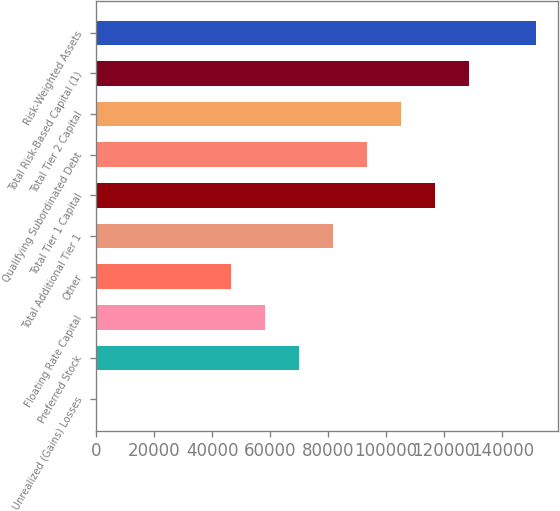Convert chart to OTSL. <chart><loc_0><loc_0><loc_500><loc_500><bar_chart><fcel>Net Unrealized (Gains) Losses<fcel>Preferred Stock<fcel>Floating Rate Capital<fcel>Other<fcel>Total Additional Tier 1<fcel>Total Tier 1 Capital<fcel>Qualifying Subordinated Debt<fcel>Total Tier 2 Capital<fcel>Total Risk-Based Capital (1)<fcel>Risk-Weighted Assets<nl><fcel>1.8<fcel>70050.5<fcel>58375.7<fcel>46700.9<fcel>81725.3<fcel>116750<fcel>93400<fcel>105075<fcel>128424<fcel>151774<nl></chart> 